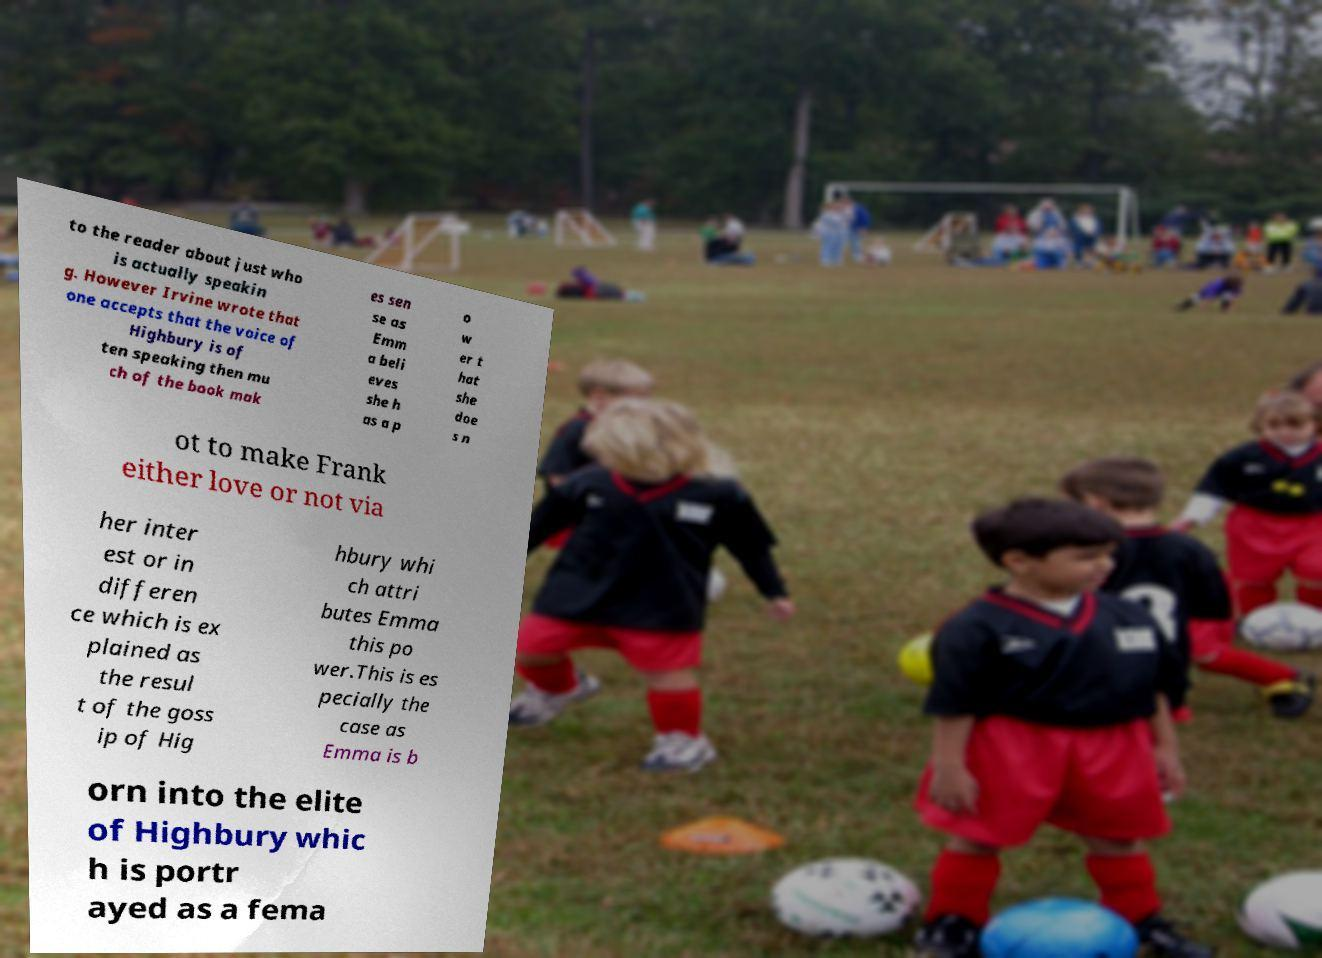Could you extract and type out the text from this image? to the reader about just who is actually speakin g. However Irvine wrote that one accepts that the voice of Highbury is of ten speaking then mu ch of the book mak es sen se as Emm a beli eves she h as a p o w er t hat she doe s n ot to make Frank either love or not via her inter est or in differen ce which is ex plained as the resul t of the goss ip of Hig hbury whi ch attri butes Emma this po wer.This is es pecially the case as Emma is b orn into the elite of Highbury whic h is portr ayed as a fema 